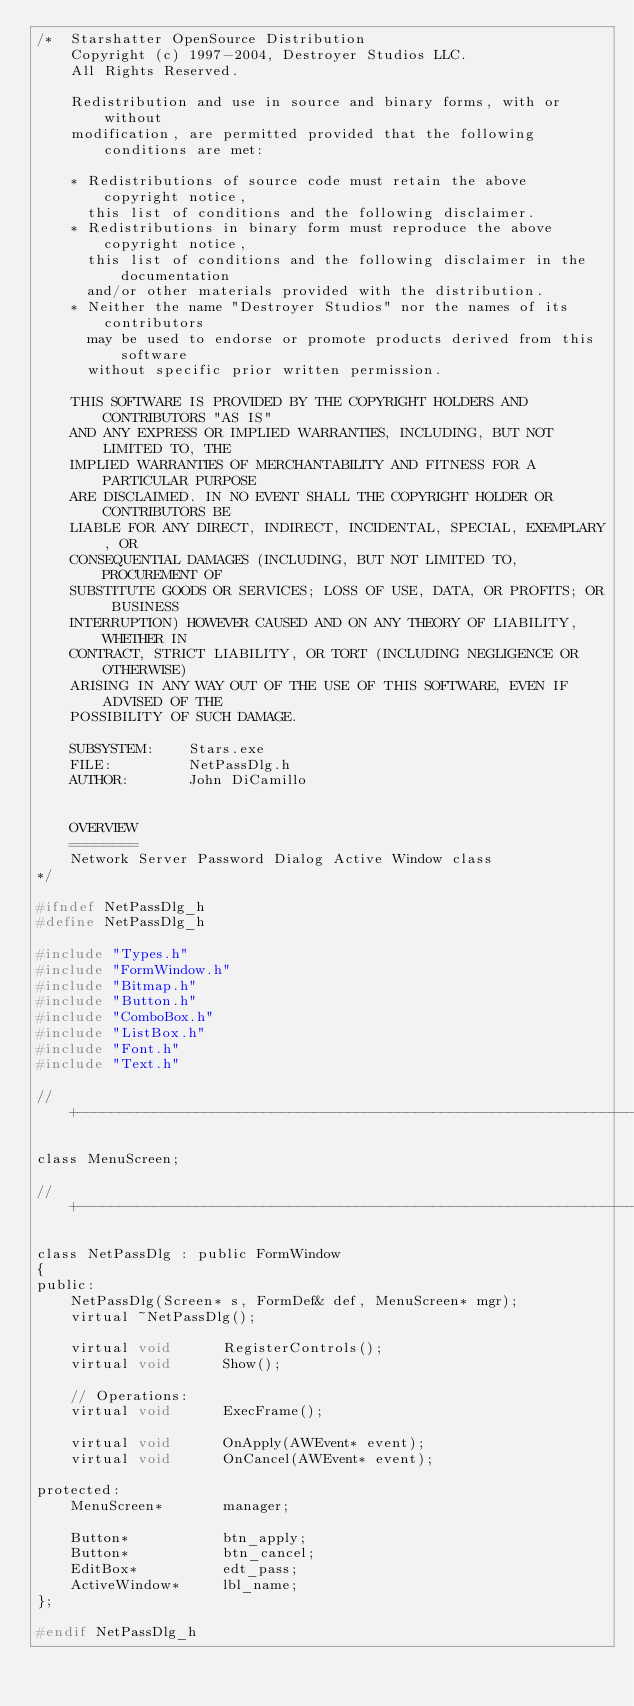<code> <loc_0><loc_0><loc_500><loc_500><_C_>/*  Starshatter OpenSource Distribution
    Copyright (c) 1997-2004, Destroyer Studios LLC.
    All Rights Reserved.

    Redistribution and use in source and binary forms, with or without
    modification, are permitted provided that the following conditions are met:

    * Redistributions of source code must retain the above copyright notice,
      this list of conditions and the following disclaimer.
    * Redistributions in binary form must reproduce the above copyright notice,
      this list of conditions and the following disclaimer in the documentation
      and/or other materials provided with the distribution.
    * Neither the name "Destroyer Studios" nor the names of its contributors
      may be used to endorse or promote products derived from this software
      without specific prior written permission.

    THIS SOFTWARE IS PROVIDED BY THE COPYRIGHT HOLDERS AND CONTRIBUTORS "AS IS"
    AND ANY EXPRESS OR IMPLIED WARRANTIES, INCLUDING, BUT NOT LIMITED TO, THE
    IMPLIED WARRANTIES OF MERCHANTABILITY AND FITNESS FOR A PARTICULAR PURPOSE
    ARE DISCLAIMED. IN NO EVENT SHALL THE COPYRIGHT HOLDER OR CONTRIBUTORS BE
    LIABLE FOR ANY DIRECT, INDIRECT, INCIDENTAL, SPECIAL, EXEMPLARY, OR
    CONSEQUENTIAL DAMAGES (INCLUDING, BUT NOT LIMITED TO, PROCUREMENT OF
    SUBSTITUTE GOODS OR SERVICES; LOSS OF USE, DATA, OR PROFITS; OR BUSINESS
    INTERRUPTION) HOWEVER CAUSED AND ON ANY THEORY OF LIABILITY, WHETHER IN
    CONTRACT, STRICT LIABILITY, OR TORT (INCLUDING NEGLIGENCE OR OTHERWISE)
    ARISING IN ANY WAY OUT OF THE USE OF THIS SOFTWARE, EVEN IF ADVISED OF THE
    POSSIBILITY OF SUCH DAMAGE.

    SUBSYSTEM:    Stars.exe
    FILE:         NetPassDlg.h
    AUTHOR:       John DiCamillo


    OVERVIEW
    ========
    Network Server Password Dialog Active Window class
*/

#ifndef NetPassDlg_h
#define NetPassDlg_h

#include "Types.h"
#include "FormWindow.h"
#include "Bitmap.h"
#include "Button.h"
#include "ComboBox.h"
#include "ListBox.h"
#include "Font.h"
#include "Text.h"

// +--------------------------------------------------------------------+

class MenuScreen;

// +--------------------------------------------------------------------+

class NetPassDlg : public FormWindow
{
public:
    NetPassDlg(Screen* s, FormDef& def, MenuScreen* mgr);
    virtual ~NetPassDlg();

    virtual void      RegisterControls();
    virtual void      Show();

    // Operations:
    virtual void      ExecFrame();

    virtual void      OnApply(AWEvent* event);
    virtual void      OnCancel(AWEvent* event);

protected:
    MenuScreen*       manager;

    Button*           btn_apply;
    Button*           btn_cancel;
    EditBox*          edt_pass;
    ActiveWindow*     lbl_name;
};

#endif NetPassDlg_h

</code> 